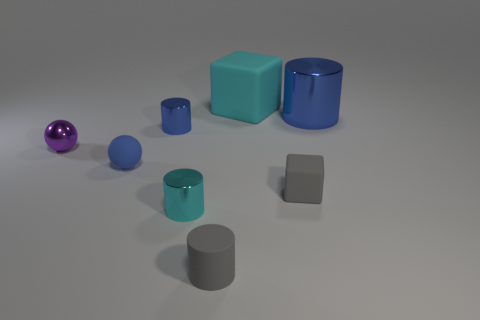Do the large cylinder that is on the right side of the small cyan shiny cylinder and the tiny purple object have the same material?
Offer a terse response. Yes. What color is the large object that is in front of the big cyan block?
Give a very brief answer. Blue. Are there any blue metal objects of the same size as the blue matte ball?
Your answer should be very brief. Yes. What material is the blue cylinder that is the same size as the rubber ball?
Make the answer very short. Metal. Is the size of the gray cube the same as the purple sphere that is left of the big rubber block?
Give a very brief answer. Yes. What is the material of the cyan thing that is behind the small cyan thing?
Provide a short and direct response. Rubber. Is the number of blue rubber things right of the large blue cylinder the same as the number of matte cylinders?
Keep it short and to the point. No. Is the gray cylinder the same size as the cyan cube?
Make the answer very short. No. Is there a purple thing that is behind the ball on the left side of the tiny sphere in front of the purple metallic object?
Provide a succinct answer. No. What is the material of the tiny cyan object that is the same shape as the large blue shiny object?
Your response must be concise. Metal. 